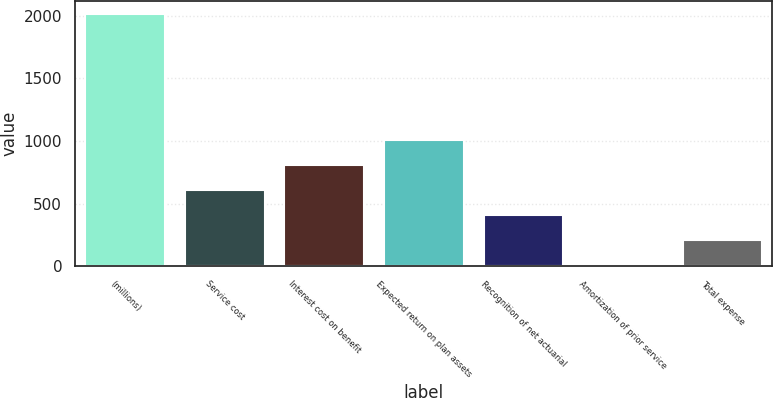Convert chart. <chart><loc_0><loc_0><loc_500><loc_500><bar_chart><fcel>(millions)<fcel>Service cost<fcel>Interest cost on benefit<fcel>Expected return on plan assets<fcel>Recognition of net actuarial<fcel>Amortization of prior service<fcel>Total expense<nl><fcel>2016<fcel>609.63<fcel>810.54<fcel>1011.45<fcel>408.72<fcel>6.9<fcel>207.81<nl></chart> 